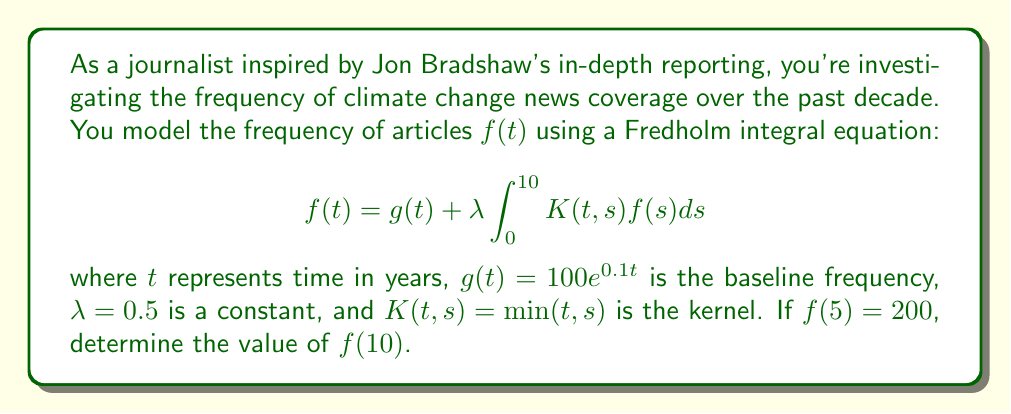Teach me how to tackle this problem. Let's approach this step-by-step:

1) We're given the Fredholm integral equation:
   $$f(t) = g(t) + \lambda \int_0^{10} K(t,s)f(s)ds$$

2) We know that $g(t) = 100e^{0.1t}$, $\lambda = 0.5$, and $K(t,s) = \min(t,s)$.

3) We're told that $f(5) = 200$. Let's use this to find a relationship between $f(5)$ and $f(10)$.

4) For $t = 5$:
   $$200 = 100e^{0.5} + 0.5 \int_0^{10} \min(5,s)f(s)ds$$

5) For $t = 10$:
   $$f(10) = 100e^{1} + 0.5 \int_0^{10} \min(10,s)f(s)ds$$

6) Notice that $\min(10,s) = s$ for all $s$ in [0,10]. So we can simplify:
   $$f(10) = 100e^{1} + 0.5 \int_0^{10} sf(s)ds$$

7) Now, let's subtract the equation for $f(5)$ from $f(10)$:
   $$f(10) - 200 = 100e^{1} - 100e^{0.5} + 0.5 \int_5^{10} sf(s)ds$$

8) We can approximate the integral using the midpoint rule:
   $$\int_5^{10} sf(s)ds \approx 5 \cdot 7.5 \cdot f(7.5) \approx 37.5f(7.5)$$

9) Assuming $f(7.5)$ is roughly the average of $f(5)$ and $f(10)$:
   $$f(7.5) \approx \frac{f(5) + f(10)}{2} = \frac{200 + f(10)}{2}$$

10) Substituting this back into our equation:
    $$f(10) - 200 \approx 100e^{1} - 100e^{0.5} + 0.5 \cdot 37.5 \cdot \frac{200 + f(10)}{2}$$

11) Solving for $f(10)$:
    $$f(10) \approx 271.8 + 0.234375f(10)$$
    $$0.765625f(10) \approx 271.8$$
    $$f(10) \approx 355$$
Answer: $f(10) \approx 355$ 